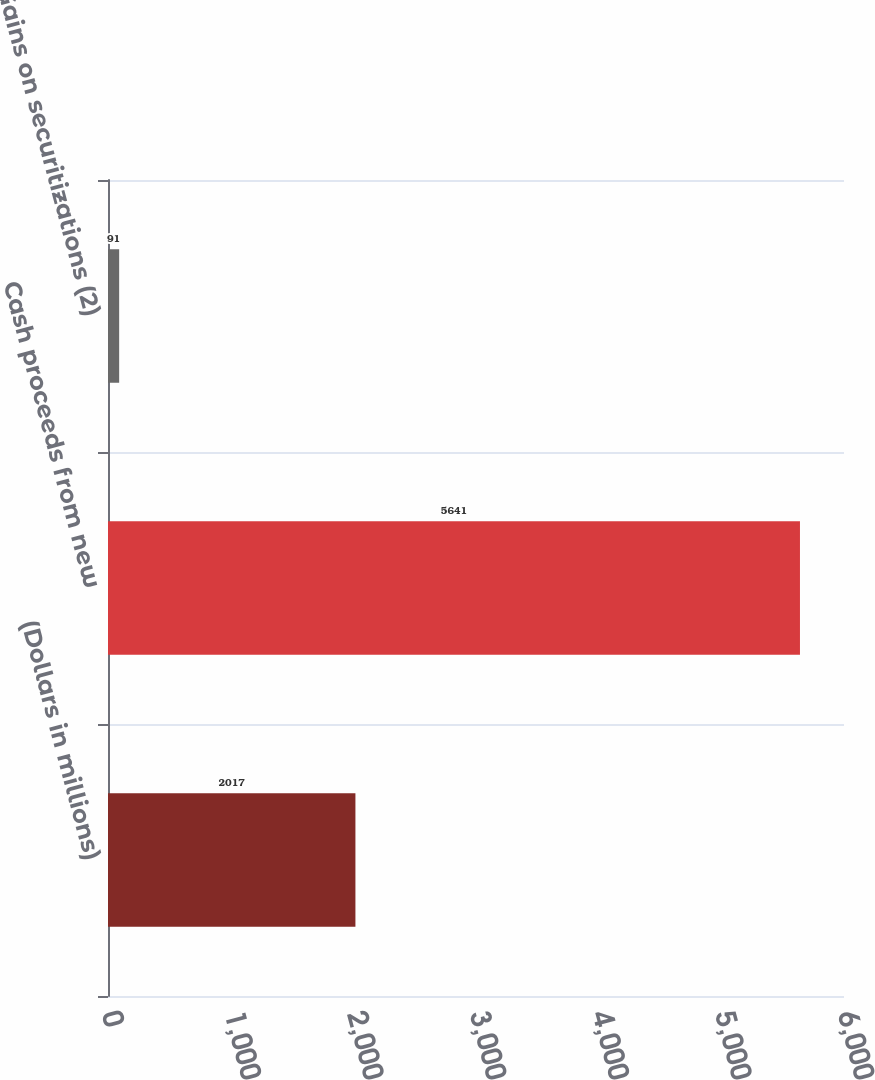<chart> <loc_0><loc_0><loc_500><loc_500><bar_chart><fcel>(Dollars in millions)<fcel>Cash proceeds from new<fcel>Gains on securitizations (2)<nl><fcel>2017<fcel>5641<fcel>91<nl></chart> 